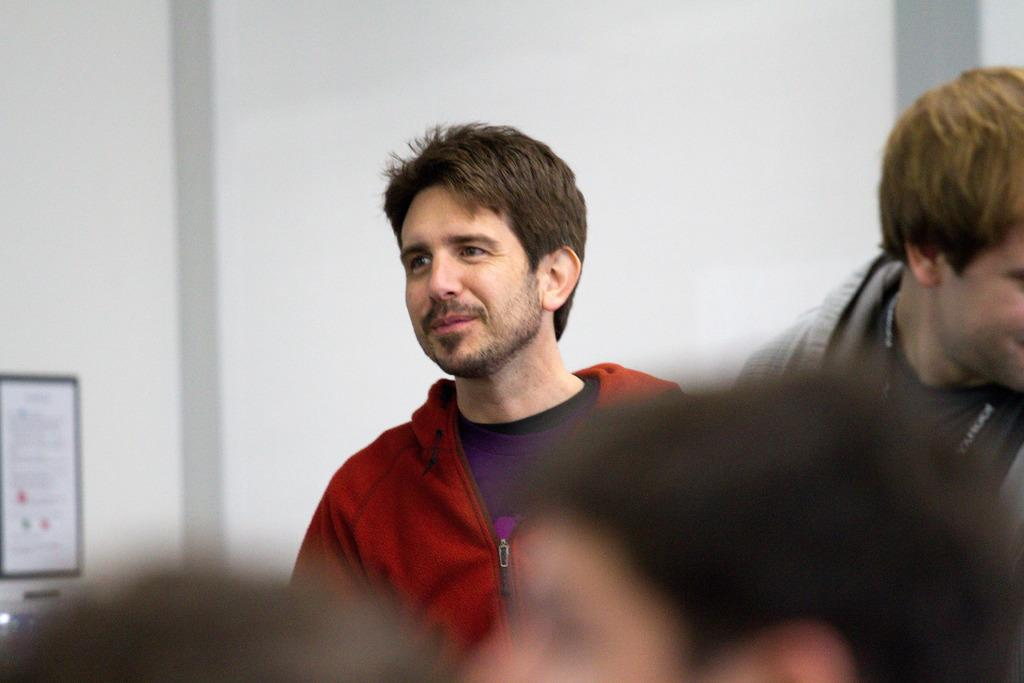What is the main subject of the image? The main subject of the image is a boy. What is the boy wearing? The boy is wearing a red hoodie. What is the boy's posture in the image? The boy is standing in front of the camera. What is the boy's facial expression? The boy is smiling. What direction is the boy looking? The boy is looking to the left side. What can be seen in the background of the image? There is a white wall in the background. Is the boy eating lunch in the image? There is no indication in the image that the boy is eating lunch. 